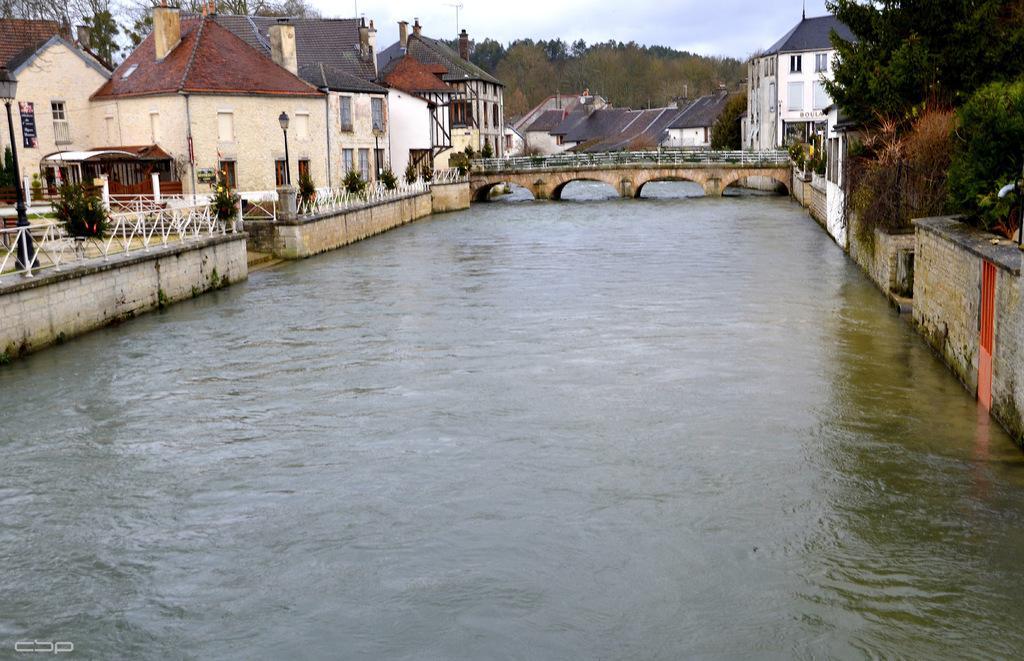In one or two sentences, can you explain what this image depicts? in this image in the front there is water. In the center there is a bridge and on the left side there are buildings, plants, poles. On the right side there are trees and there is a building and there is a wall. In the background there are trees and the sky is cloudy. 